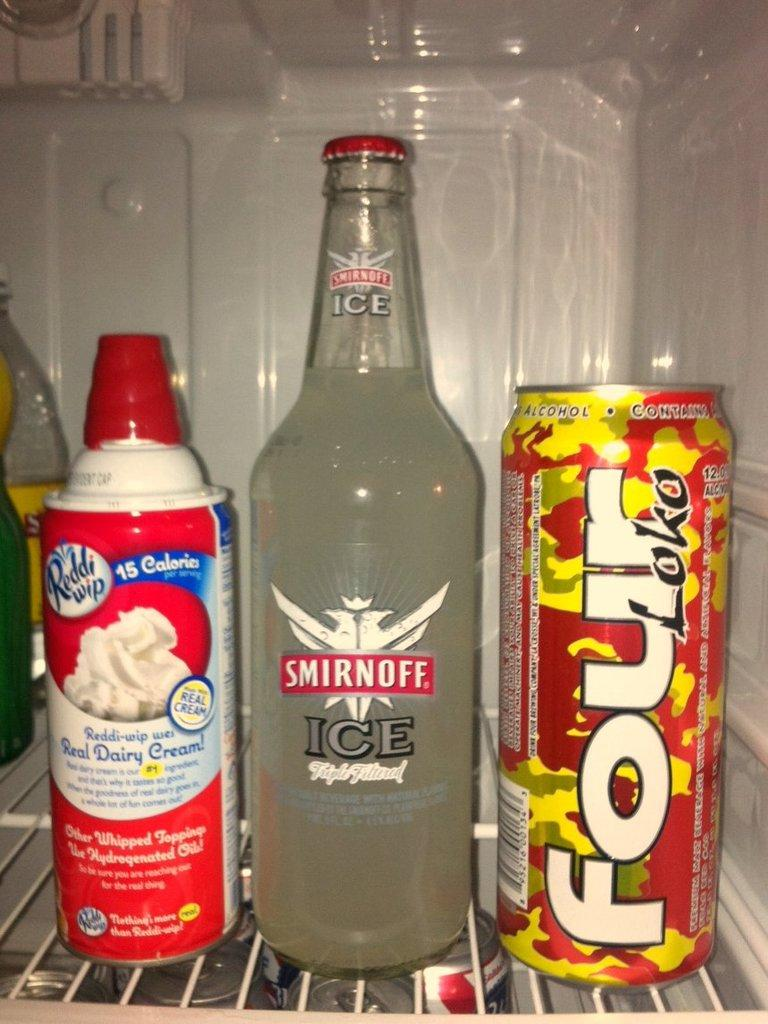<image>
Offer a succinct explanation of the picture presented. Bottle of Smirnoff Ice sits on the fridge shelf between Rddi wip and Four Loko. 